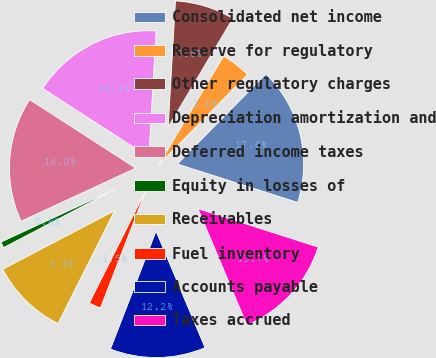<chart> <loc_0><loc_0><loc_500><loc_500><pie_chart><fcel>Consolidated net income<fcel>Reserve for regulatory<fcel>Other regulatory charges<fcel>Depreciation amortization and<fcel>Deferred income taxes<fcel>Equity in losses of<fcel>Receivables<fcel>Fuel inventory<fcel>Accounts payable<fcel>Taxes accrued<nl><fcel>17.55%<fcel>3.82%<fcel>7.63%<fcel>16.79%<fcel>16.03%<fcel>0.77%<fcel>9.92%<fcel>1.53%<fcel>12.21%<fcel>13.74%<nl></chart> 